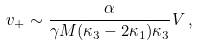Convert formula to latex. <formula><loc_0><loc_0><loc_500><loc_500>v _ { + } \sim \frac { \alpha } { \gamma M ( \kappa _ { 3 } - 2 \kappa _ { 1 } ) \kappa _ { 3 } } V \, ,</formula> 